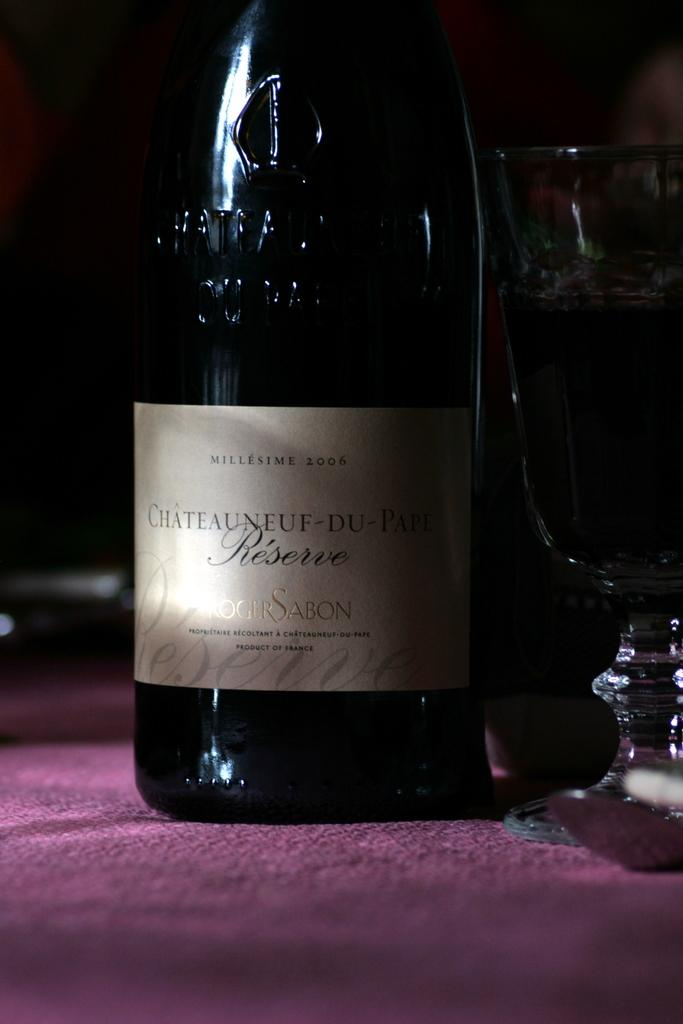<image>
Share a concise interpretation of the image provided. Wine bottle with a label that syas "SABON" on it. 